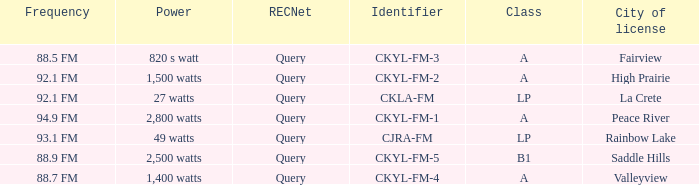What is the city of license that has a 1,400 watts power Valleyview. 